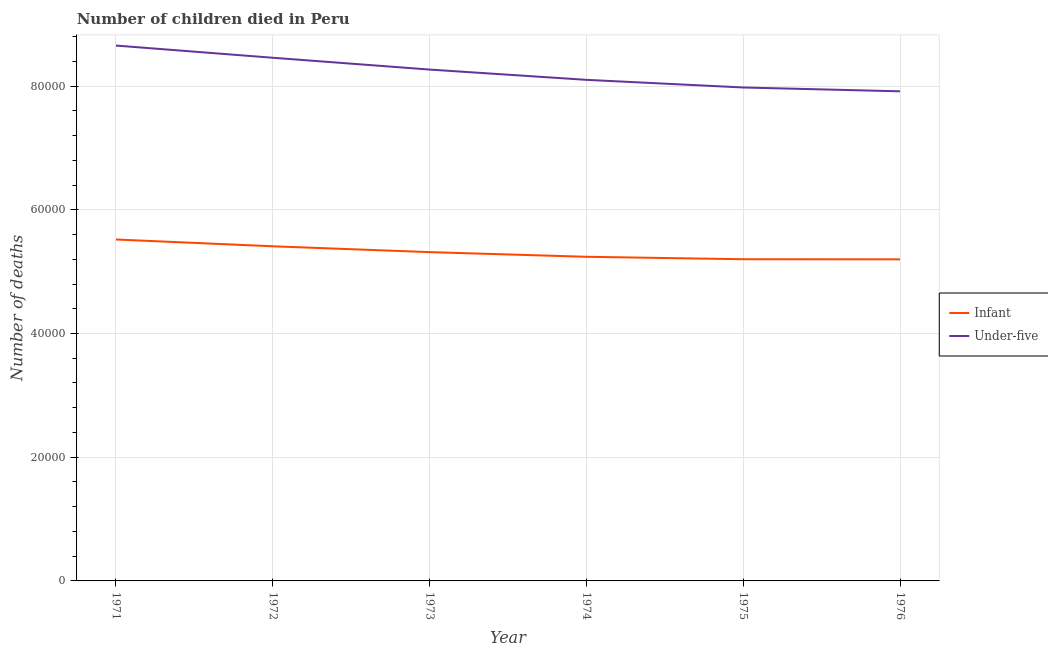How many different coloured lines are there?
Keep it short and to the point. 2. Does the line corresponding to number of under-five deaths intersect with the line corresponding to number of infant deaths?
Give a very brief answer. No. Is the number of lines equal to the number of legend labels?
Make the answer very short. Yes. What is the number of infant deaths in 1975?
Offer a terse response. 5.20e+04. Across all years, what is the maximum number of under-five deaths?
Make the answer very short. 8.65e+04. Across all years, what is the minimum number of infant deaths?
Keep it short and to the point. 5.20e+04. In which year was the number of infant deaths maximum?
Keep it short and to the point. 1971. In which year was the number of under-five deaths minimum?
Give a very brief answer. 1976. What is the total number of under-five deaths in the graph?
Offer a very short reply. 4.94e+05. What is the difference between the number of infant deaths in 1971 and that in 1976?
Your response must be concise. 3209. What is the difference between the number of infant deaths in 1972 and the number of under-five deaths in 1971?
Provide a short and direct response. -3.24e+04. What is the average number of infant deaths per year?
Ensure brevity in your answer.  5.31e+04. In the year 1972, what is the difference between the number of under-five deaths and number of infant deaths?
Your answer should be very brief. 3.05e+04. What is the ratio of the number of infant deaths in 1972 to that in 1975?
Your response must be concise. 1.04. Is the number of under-five deaths in 1971 less than that in 1975?
Give a very brief answer. No. Is the difference between the number of infant deaths in 1972 and 1974 greater than the difference between the number of under-five deaths in 1972 and 1974?
Offer a terse response. No. What is the difference between the highest and the second highest number of under-five deaths?
Your answer should be very brief. 1971. What is the difference between the highest and the lowest number of under-five deaths?
Offer a very short reply. 7397. In how many years, is the number of infant deaths greater than the average number of infant deaths taken over all years?
Offer a terse response. 3. Is the sum of the number of under-five deaths in 1971 and 1972 greater than the maximum number of infant deaths across all years?
Your response must be concise. Yes. Is the number of under-five deaths strictly greater than the number of infant deaths over the years?
Your answer should be compact. Yes. Is the number of infant deaths strictly less than the number of under-five deaths over the years?
Your response must be concise. Yes. How many lines are there?
Offer a terse response. 2. What is the difference between two consecutive major ticks on the Y-axis?
Ensure brevity in your answer.  2.00e+04. Does the graph contain grids?
Offer a terse response. Yes. Where does the legend appear in the graph?
Your answer should be compact. Center right. How are the legend labels stacked?
Your response must be concise. Vertical. What is the title of the graph?
Keep it short and to the point. Number of children died in Peru. What is the label or title of the Y-axis?
Provide a short and direct response. Number of deaths. What is the Number of deaths in Infant in 1971?
Ensure brevity in your answer.  5.52e+04. What is the Number of deaths of Under-five in 1971?
Your answer should be very brief. 8.65e+04. What is the Number of deaths in Infant in 1972?
Ensure brevity in your answer.  5.41e+04. What is the Number of deaths in Under-five in 1972?
Offer a very short reply. 8.46e+04. What is the Number of deaths of Infant in 1973?
Provide a succinct answer. 5.32e+04. What is the Number of deaths of Under-five in 1973?
Give a very brief answer. 8.27e+04. What is the Number of deaths in Infant in 1974?
Give a very brief answer. 5.24e+04. What is the Number of deaths of Under-five in 1974?
Your answer should be compact. 8.10e+04. What is the Number of deaths of Infant in 1975?
Make the answer very short. 5.20e+04. What is the Number of deaths of Under-five in 1975?
Offer a very short reply. 7.98e+04. What is the Number of deaths of Infant in 1976?
Offer a terse response. 5.20e+04. What is the Number of deaths of Under-five in 1976?
Ensure brevity in your answer.  7.92e+04. Across all years, what is the maximum Number of deaths in Infant?
Make the answer very short. 5.52e+04. Across all years, what is the maximum Number of deaths in Under-five?
Keep it short and to the point. 8.65e+04. Across all years, what is the minimum Number of deaths of Infant?
Keep it short and to the point. 5.20e+04. Across all years, what is the minimum Number of deaths in Under-five?
Keep it short and to the point. 7.92e+04. What is the total Number of deaths in Infant in the graph?
Provide a short and direct response. 3.19e+05. What is the total Number of deaths of Under-five in the graph?
Provide a succinct answer. 4.94e+05. What is the difference between the Number of deaths in Infant in 1971 and that in 1972?
Your response must be concise. 1096. What is the difference between the Number of deaths in Under-five in 1971 and that in 1972?
Offer a terse response. 1971. What is the difference between the Number of deaths in Infant in 1971 and that in 1973?
Make the answer very short. 2042. What is the difference between the Number of deaths of Under-five in 1971 and that in 1973?
Your answer should be very brief. 3879. What is the difference between the Number of deaths in Infant in 1971 and that in 1974?
Give a very brief answer. 2795. What is the difference between the Number of deaths of Under-five in 1971 and that in 1974?
Offer a very short reply. 5541. What is the difference between the Number of deaths in Infant in 1971 and that in 1975?
Your response must be concise. 3190. What is the difference between the Number of deaths of Under-five in 1971 and that in 1975?
Ensure brevity in your answer.  6778. What is the difference between the Number of deaths of Infant in 1971 and that in 1976?
Ensure brevity in your answer.  3209. What is the difference between the Number of deaths in Under-five in 1971 and that in 1976?
Give a very brief answer. 7397. What is the difference between the Number of deaths in Infant in 1972 and that in 1973?
Give a very brief answer. 946. What is the difference between the Number of deaths in Under-five in 1972 and that in 1973?
Offer a terse response. 1908. What is the difference between the Number of deaths in Infant in 1972 and that in 1974?
Offer a very short reply. 1699. What is the difference between the Number of deaths of Under-five in 1972 and that in 1974?
Offer a very short reply. 3570. What is the difference between the Number of deaths of Infant in 1972 and that in 1975?
Ensure brevity in your answer.  2094. What is the difference between the Number of deaths in Under-five in 1972 and that in 1975?
Your answer should be very brief. 4807. What is the difference between the Number of deaths of Infant in 1972 and that in 1976?
Give a very brief answer. 2113. What is the difference between the Number of deaths of Under-five in 1972 and that in 1976?
Provide a succinct answer. 5426. What is the difference between the Number of deaths of Infant in 1973 and that in 1974?
Your answer should be compact. 753. What is the difference between the Number of deaths in Under-five in 1973 and that in 1974?
Your answer should be compact. 1662. What is the difference between the Number of deaths in Infant in 1973 and that in 1975?
Provide a succinct answer. 1148. What is the difference between the Number of deaths of Under-five in 1973 and that in 1975?
Provide a succinct answer. 2899. What is the difference between the Number of deaths in Infant in 1973 and that in 1976?
Provide a short and direct response. 1167. What is the difference between the Number of deaths in Under-five in 1973 and that in 1976?
Offer a terse response. 3518. What is the difference between the Number of deaths of Infant in 1974 and that in 1975?
Make the answer very short. 395. What is the difference between the Number of deaths in Under-five in 1974 and that in 1975?
Keep it short and to the point. 1237. What is the difference between the Number of deaths of Infant in 1974 and that in 1976?
Provide a short and direct response. 414. What is the difference between the Number of deaths of Under-five in 1974 and that in 1976?
Your answer should be compact. 1856. What is the difference between the Number of deaths of Infant in 1975 and that in 1976?
Your response must be concise. 19. What is the difference between the Number of deaths in Under-five in 1975 and that in 1976?
Provide a succinct answer. 619. What is the difference between the Number of deaths of Infant in 1971 and the Number of deaths of Under-five in 1972?
Your response must be concise. -2.94e+04. What is the difference between the Number of deaths in Infant in 1971 and the Number of deaths in Under-five in 1973?
Your response must be concise. -2.75e+04. What is the difference between the Number of deaths in Infant in 1971 and the Number of deaths in Under-five in 1974?
Your answer should be compact. -2.58e+04. What is the difference between the Number of deaths in Infant in 1971 and the Number of deaths in Under-five in 1975?
Your answer should be compact. -2.46e+04. What is the difference between the Number of deaths in Infant in 1971 and the Number of deaths in Under-five in 1976?
Provide a short and direct response. -2.40e+04. What is the difference between the Number of deaths of Infant in 1972 and the Number of deaths of Under-five in 1973?
Give a very brief answer. -2.86e+04. What is the difference between the Number of deaths of Infant in 1972 and the Number of deaths of Under-five in 1974?
Give a very brief answer. -2.69e+04. What is the difference between the Number of deaths in Infant in 1972 and the Number of deaths in Under-five in 1975?
Offer a terse response. -2.57e+04. What is the difference between the Number of deaths of Infant in 1972 and the Number of deaths of Under-five in 1976?
Your answer should be compact. -2.51e+04. What is the difference between the Number of deaths of Infant in 1973 and the Number of deaths of Under-five in 1974?
Provide a succinct answer. -2.79e+04. What is the difference between the Number of deaths of Infant in 1973 and the Number of deaths of Under-five in 1975?
Provide a succinct answer. -2.66e+04. What is the difference between the Number of deaths in Infant in 1973 and the Number of deaths in Under-five in 1976?
Give a very brief answer. -2.60e+04. What is the difference between the Number of deaths of Infant in 1974 and the Number of deaths of Under-five in 1975?
Give a very brief answer. -2.74e+04. What is the difference between the Number of deaths in Infant in 1974 and the Number of deaths in Under-five in 1976?
Give a very brief answer. -2.68e+04. What is the difference between the Number of deaths of Infant in 1975 and the Number of deaths of Under-five in 1976?
Give a very brief answer. -2.71e+04. What is the average Number of deaths of Infant per year?
Your response must be concise. 5.31e+04. What is the average Number of deaths of Under-five per year?
Your response must be concise. 8.23e+04. In the year 1971, what is the difference between the Number of deaths in Infant and Number of deaths in Under-five?
Make the answer very short. -3.14e+04. In the year 1972, what is the difference between the Number of deaths in Infant and Number of deaths in Under-five?
Provide a short and direct response. -3.05e+04. In the year 1973, what is the difference between the Number of deaths in Infant and Number of deaths in Under-five?
Your answer should be very brief. -2.95e+04. In the year 1974, what is the difference between the Number of deaths of Infant and Number of deaths of Under-five?
Keep it short and to the point. -2.86e+04. In the year 1975, what is the difference between the Number of deaths in Infant and Number of deaths in Under-five?
Offer a terse response. -2.78e+04. In the year 1976, what is the difference between the Number of deaths of Infant and Number of deaths of Under-five?
Keep it short and to the point. -2.72e+04. What is the ratio of the Number of deaths in Infant in 1971 to that in 1972?
Make the answer very short. 1.02. What is the ratio of the Number of deaths in Under-five in 1971 to that in 1972?
Keep it short and to the point. 1.02. What is the ratio of the Number of deaths of Infant in 1971 to that in 1973?
Your answer should be very brief. 1.04. What is the ratio of the Number of deaths in Under-five in 1971 to that in 1973?
Offer a terse response. 1.05. What is the ratio of the Number of deaths of Infant in 1971 to that in 1974?
Provide a succinct answer. 1.05. What is the ratio of the Number of deaths in Under-five in 1971 to that in 1974?
Ensure brevity in your answer.  1.07. What is the ratio of the Number of deaths in Infant in 1971 to that in 1975?
Ensure brevity in your answer.  1.06. What is the ratio of the Number of deaths of Under-five in 1971 to that in 1975?
Offer a terse response. 1.08. What is the ratio of the Number of deaths of Infant in 1971 to that in 1976?
Provide a succinct answer. 1.06. What is the ratio of the Number of deaths of Under-five in 1971 to that in 1976?
Give a very brief answer. 1.09. What is the ratio of the Number of deaths of Infant in 1972 to that in 1973?
Keep it short and to the point. 1.02. What is the ratio of the Number of deaths in Under-five in 1972 to that in 1973?
Keep it short and to the point. 1.02. What is the ratio of the Number of deaths of Infant in 1972 to that in 1974?
Your response must be concise. 1.03. What is the ratio of the Number of deaths in Under-five in 1972 to that in 1974?
Offer a terse response. 1.04. What is the ratio of the Number of deaths of Infant in 1972 to that in 1975?
Provide a succinct answer. 1.04. What is the ratio of the Number of deaths of Under-five in 1972 to that in 1975?
Provide a short and direct response. 1.06. What is the ratio of the Number of deaths in Infant in 1972 to that in 1976?
Keep it short and to the point. 1.04. What is the ratio of the Number of deaths in Under-five in 1972 to that in 1976?
Ensure brevity in your answer.  1.07. What is the ratio of the Number of deaths in Infant in 1973 to that in 1974?
Provide a succinct answer. 1.01. What is the ratio of the Number of deaths of Under-five in 1973 to that in 1974?
Make the answer very short. 1.02. What is the ratio of the Number of deaths of Infant in 1973 to that in 1975?
Your response must be concise. 1.02. What is the ratio of the Number of deaths of Under-five in 1973 to that in 1975?
Provide a short and direct response. 1.04. What is the ratio of the Number of deaths in Infant in 1973 to that in 1976?
Make the answer very short. 1.02. What is the ratio of the Number of deaths in Under-five in 1973 to that in 1976?
Offer a terse response. 1.04. What is the ratio of the Number of deaths of Infant in 1974 to that in 1975?
Offer a terse response. 1.01. What is the ratio of the Number of deaths in Under-five in 1974 to that in 1975?
Your response must be concise. 1.02. What is the ratio of the Number of deaths in Infant in 1974 to that in 1976?
Your response must be concise. 1.01. What is the ratio of the Number of deaths in Under-five in 1974 to that in 1976?
Give a very brief answer. 1.02. What is the ratio of the Number of deaths of Infant in 1975 to that in 1976?
Your answer should be compact. 1. What is the ratio of the Number of deaths in Under-five in 1975 to that in 1976?
Provide a short and direct response. 1.01. What is the difference between the highest and the second highest Number of deaths of Infant?
Ensure brevity in your answer.  1096. What is the difference between the highest and the second highest Number of deaths in Under-five?
Ensure brevity in your answer.  1971. What is the difference between the highest and the lowest Number of deaths of Infant?
Offer a terse response. 3209. What is the difference between the highest and the lowest Number of deaths in Under-five?
Ensure brevity in your answer.  7397. 